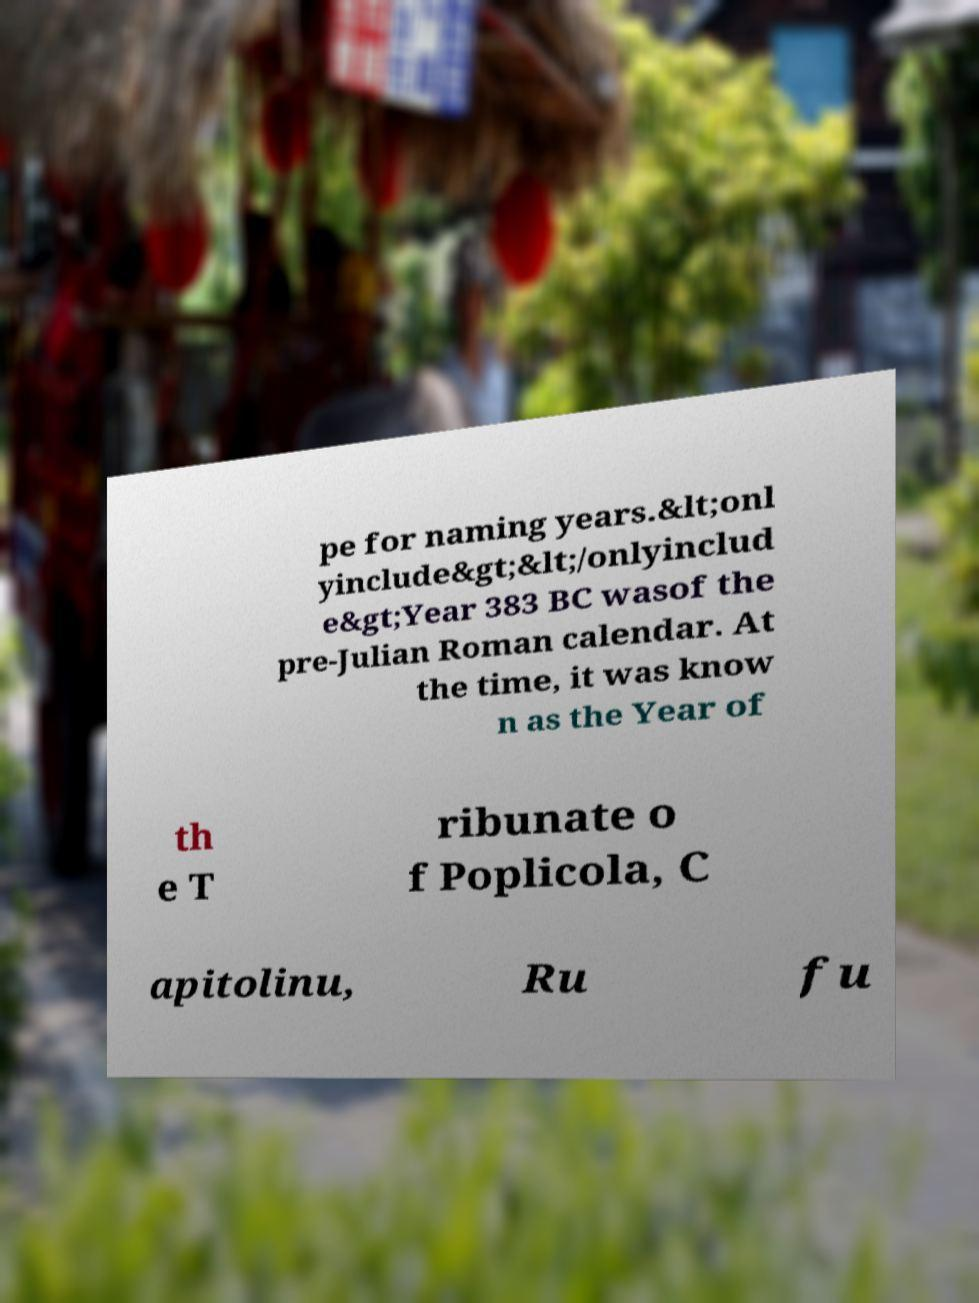Can you read and provide the text displayed in the image?This photo seems to have some interesting text. Can you extract and type it out for me? pe for naming years.&lt;onl yinclude&gt;&lt;/onlyinclud e&gt;Year 383 BC wasof the pre-Julian Roman calendar. At the time, it was know n as the Year of th e T ribunate o f Poplicola, C apitolinu, Ru fu 